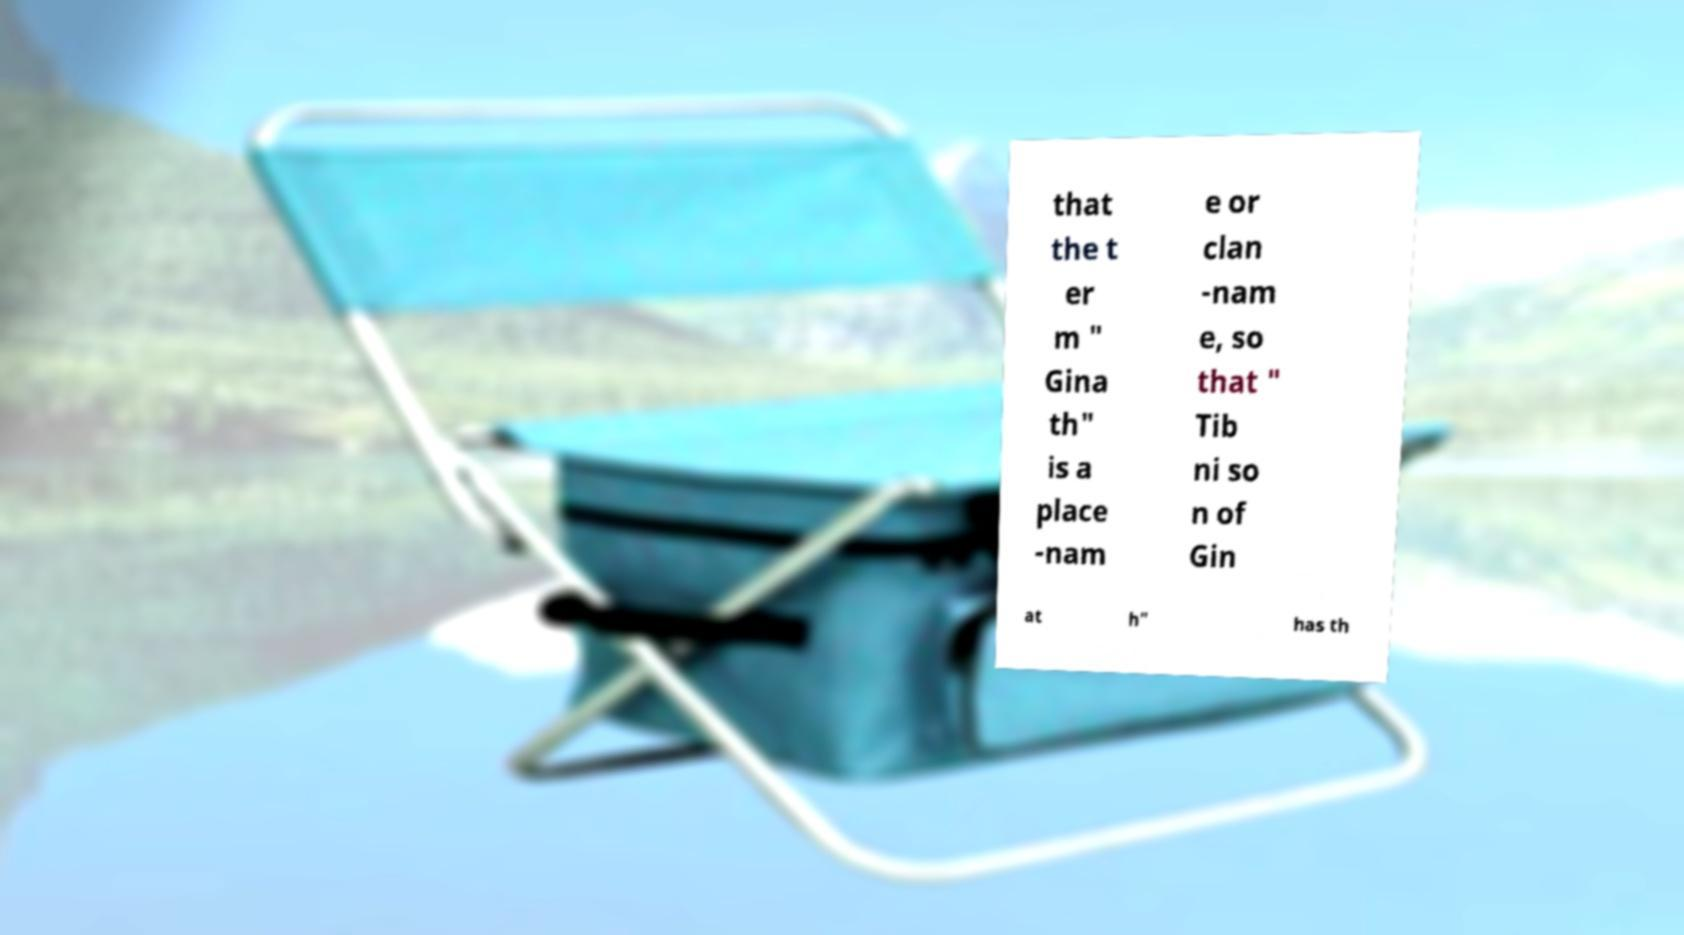Can you accurately transcribe the text from the provided image for me? that the t er m " Gina th" is a place -nam e or clan -nam e, so that " Tib ni so n of Gin at h" has th 